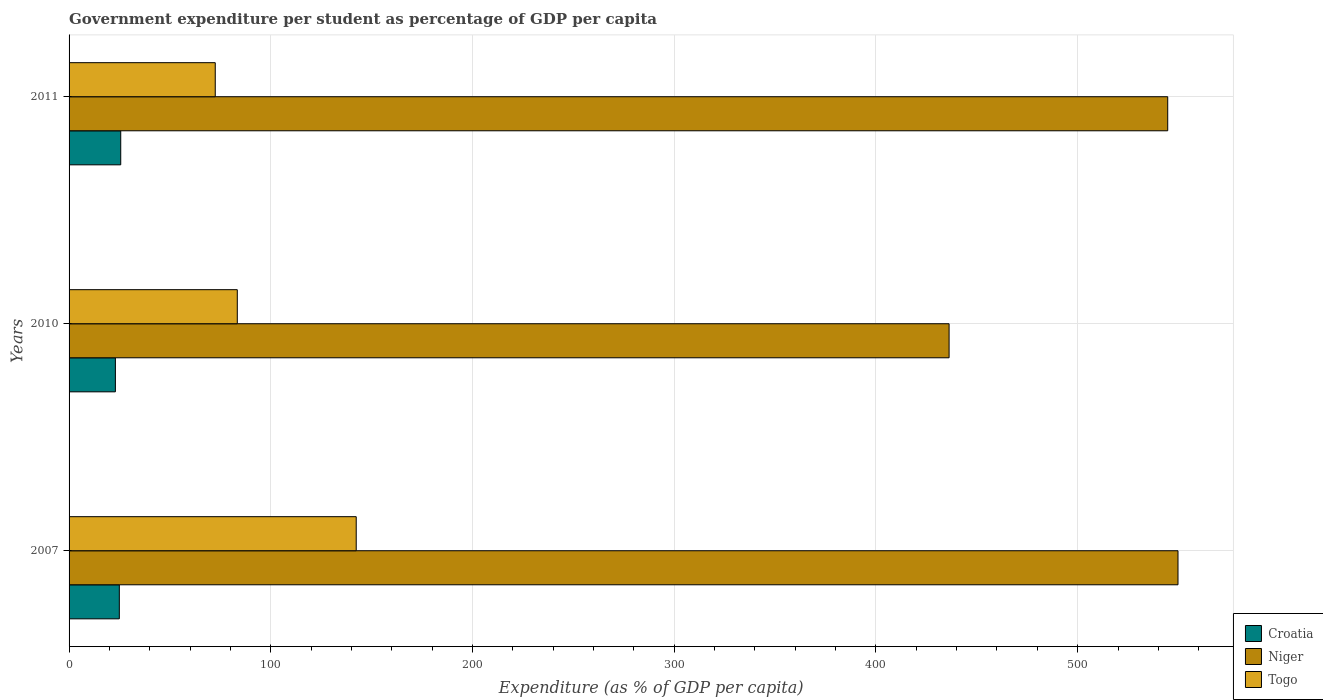How many different coloured bars are there?
Offer a very short reply. 3. Are the number of bars per tick equal to the number of legend labels?
Ensure brevity in your answer.  Yes. How many bars are there on the 2nd tick from the top?
Keep it short and to the point. 3. How many bars are there on the 3rd tick from the bottom?
Keep it short and to the point. 3. What is the percentage of expenditure per student in Niger in 2011?
Offer a very short reply. 544.64. Across all years, what is the maximum percentage of expenditure per student in Togo?
Give a very brief answer. 142.35. Across all years, what is the minimum percentage of expenditure per student in Togo?
Provide a short and direct response. 72.47. In which year was the percentage of expenditure per student in Togo minimum?
Your response must be concise. 2011. What is the total percentage of expenditure per student in Togo in the graph?
Your answer should be very brief. 298.22. What is the difference between the percentage of expenditure per student in Croatia in 2007 and that in 2011?
Provide a succinct answer. -0.7. What is the difference between the percentage of expenditure per student in Niger in 2011 and the percentage of expenditure per student in Togo in 2007?
Make the answer very short. 402.29. What is the average percentage of expenditure per student in Togo per year?
Make the answer very short. 99.41. In the year 2010, what is the difference between the percentage of expenditure per student in Niger and percentage of expenditure per student in Togo?
Give a very brief answer. 352.86. In how many years, is the percentage of expenditure per student in Togo greater than 480 %?
Make the answer very short. 0. What is the ratio of the percentage of expenditure per student in Croatia in 2010 to that in 2011?
Ensure brevity in your answer.  0.9. Is the percentage of expenditure per student in Niger in 2007 less than that in 2010?
Offer a terse response. No. Is the difference between the percentage of expenditure per student in Niger in 2007 and 2010 greater than the difference between the percentage of expenditure per student in Togo in 2007 and 2010?
Provide a succinct answer. Yes. What is the difference between the highest and the second highest percentage of expenditure per student in Niger?
Provide a short and direct response. 5.1. What is the difference between the highest and the lowest percentage of expenditure per student in Niger?
Keep it short and to the point. 113.48. In how many years, is the percentage of expenditure per student in Croatia greater than the average percentage of expenditure per student in Croatia taken over all years?
Your response must be concise. 2. What does the 1st bar from the top in 2007 represents?
Offer a very short reply. Togo. What does the 2nd bar from the bottom in 2011 represents?
Offer a terse response. Niger. Is it the case that in every year, the sum of the percentage of expenditure per student in Togo and percentage of expenditure per student in Niger is greater than the percentage of expenditure per student in Croatia?
Your response must be concise. Yes. Are all the bars in the graph horizontal?
Your answer should be very brief. Yes. How many years are there in the graph?
Your response must be concise. 3. What is the difference between two consecutive major ticks on the X-axis?
Give a very brief answer. 100. How are the legend labels stacked?
Offer a terse response. Vertical. What is the title of the graph?
Keep it short and to the point. Government expenditure per student as percentage of GDP per capita. What is the label or title of the X-axis?
Your answer should be very brief. Expenditure (as % of GDP per capita). What is the label or title of the Y-axis?
Your answer should be compact. Years. What is the Expenditure (as % of GDP per capita) in Croatia in 2007?
Your response must be concise. 24.92. What is the Expenditure (as % of GDP per capita) of Niger in 2007?
Provide a succinct answer. 549.74. What is the Expenditure (as % of GDP per capita) in Togo in 2007?
Your answer should be very brief. 142.35. What is the Expenditure (as % of GDP per capita) in Croatia in 2010?
Give a very brief answer. 22.96. What is the Expenditure (as % of GDP per capita) in Niger in 2010?
Your answer should be very brief. 436.26. What is the Expenditure (as % of GDP per capita) in Togo in 2010?
Make the answer very short. 83.4. What is the Expenditure (as % of GDP per capita) in Croatia in 2011?
Your answer should be compact. 25.61. What is the Expenditure (as % of GDP per capita) in Niger in 2011?
Ensure brevity in your answer.  544.64. What is the Expenditure (as % of GDP per capita) of Togo in 2011?
Your answer should be compact. 72.47. Across all years, what is the maximum Expenditure (as % of GDP per capita) of Croatia?
Your answer should be compact. 25.61. Across all years, what is the maximum Expenditure (as % of GDP per capita) in Niger?
Offer a terse response. 549.74. Across all years, what is the maximum Expenditure (as % of GDP per capita) in Togo?
Offer a very short reply. 142.35. Across all years, what is the minimum Expenditure (as % of GDP per capita) of Croatia?
Provide a short and direct response. 22.96. Across all years, what is the minimum Expenditure (as % of GDP per capita) in Niger?
Offer a very short reply. 436.26. Across all years, what is the minimum Expenditure (as % of GDP per capita) of Togo?
Give a very brief answer. 72.47. What is the total Expenditure (as % of GDP per capita) in Croatia in the graph?
Ensure brevity in your answer.  73.49. What is the total Expenditure (as % of GDP per capita) of Niger in the graph?
Your response must be concise. 1530.64. What is the total Expenditure (as % of GDP per capita) of Togo in the graph?
Keep it short and to the point. 298.21. What is the difference between the Expenditure (as % of GDP per capita) of Croatia in 2007 and that in 2010?
Offer a terse response. 1.96. What is the difference between the Expenditure (as % of GDP per capita) in Niger in 2007 and that in 2010?
Offer a terse response. 113.48. What is the difference between the Expenditure (as % of GDP per capita) in Togo in 2007 and that in 2010?
Offer a terse response. 58.95. What is the difference between the Expenditure (as % of GDP per capita) in Croatia in 2007 and that in 2011?
Keep it short and to the point. -0.7. What is the difference between the Expenditure (as % of GDP per capita) in Niger in 2007 and that in 2011?
Offer a very short reply. 5.09. What is the difference between the Expenditure (as % of GDP per capita) of Togo in 2007 and that in 2011?
Offer a very short reply. 69.88. What is the difference between the Expenditure (as % of GDP per capita) in Croatia in 2010 and that in 2011?
Your answer should be very brief. -2.65. What is the difference between the Expenditure (as % of GDP per capita) in Niger in 2010 and that in 2011?
Your answer should be compact. -108.39. What is the difference between the Expenditure (as % of GDP per capita) of Togo in 2010 and that in 2011?
Your answer should be very brief. 10.93. What is the difference between the Expenditure (as % of GDP per capita) of Croatia in 2007 and the Expenditure (as % of GDP per capita) of Niger in 2010?
Provide a short and direct response. -411.34. What is the difference between the Expenditure (as % of GDP per capita) of Croatia in 2007 and the Expenditure (as % of GDP per capita) of Togo in 2010?
Give a very brief answer. -58.48. What is the difference between the Expenditure (as % of GDP per capita) of Niger in 2007 and the Expenditure (as % of GDP per capita) of Togo in 2010?
Your answer should be compact. 466.34. What is the difference between the Expenditure (as % of GDP per capita) in Croatia in 2007 and the Expenditure (as % of GDP per capita) in Niger in 2011?
Keep it short and to the point. -519.73. What is the difference between the Expenditure (as % of GDP per capita) in Croatia in 2007 and the Expenditure (as % of GDP per capita) in Togo in 2011?
Give a very brief answer. -47.55. What is the difference between the Expenditure (as % of GDP per capita) of Niger in 2007 and the Expenditure (as % of GDP per capita) of Togo in 2011?
Give a very brief answer. 477.27. What is the difference between the Expenditure (as % of GDP per capita) of Croatia in 2010 and the Expenditure (as % of GDP per capita) of Niger in 2011?
Offer a terse response. -521.68. What is the difference between the Expenditure (as % of GDP per capita) in Croatia in 2010 and the Expenditure (as % of GDP per capita) in Togo in 2011?
Your answer should be compact. -49.51. What is the difference between the Expenditure (as % of GDP per capita) of Niger in 2010 and the Expenditure (as % of GDP per capita) of Togo in 2011?
Provide a short and direct response. 363.79. What is the average Expenditure (as % of GDP per capita) in Croatia per year?
Make the answer very short. 24.5. What is the average Expenditure (as % of GDP per capita) in Niger per year?
Your answer should be very brief. 510.21. What is the average Expenditure (as % of GDP per capita) in Togo per year?
Keep it short and to the point. 99.41. In the year 2007, what is the difference between the Expenditure (as % of GDP per capita) of Croatia and Expenditure (as % of GDP per capita) of Niger?
Ensure brevity in your answer.  -524.82. In the year 2007, what is the difference between the Expenditure (as % of GDP per capita) of Croatia and Expenditure (as % of GDP per capita) of Togo?
Give a very brief answer. -117.43. In the year 2007, what is the difference between the Expenditure (as % of GDP per capita) in Niger and Expenditure (as % of GDP per capita) in Togo?
Offer a very short reply. 407.39. In the year 2010, what is the difference between the Expenditure (as % of GDP per capita) of Croatia and Expenditure (as % of GDP per capita) of Niger?
Offer a terse response. -413.3. In the year 2010, what is the difference between the Expenditure (as % of GDP per capita) in Croatia and Expenditure (as % of GDP per capita) in Togo?
Offer a terse response. -60.44. In the year 2010, what is the difference between the Expenditure (as % of GDP per capita) in Niger and Expenditure (as % of GDP per capita) in Togo?
Provide a succinct answer. 352.86. In the year 2011, what is the difference between the Expenditure (as % of GDP per capita) of Croatia and Expenditure (as % of GDP per capita) of Niger?
Provide a short and direct response. -519.03. In the year 2011, what is the difference between the Expenditure (as % of GDP per capita) of Croatia and Expenditure (as % of GDP per capita) of Togo?
Provide a short and direct response. -46.85. In the year 2011, what is the difference between the Expenditure (as % of GDP per capita) in Niger and Expenditure (as % of GDP per capita) in Togo?
Keep it short and to the point. 472.18. What is the ratio of the Expenditure (as % of GDP per capita) of Croatia in 2007 to that in 2010?
Offer a terse response. 1.09. What is the ratio of the Expenditure (as % of GDP per capita) of Niger in 2007 to that in 2010?
Keep it short and to the point. 1.26. What is the ratio of the Expenditure (as % of GDP per capita) of Togo in 2007 to that in 2010?
Offer a very short reply. 1.71. What is the ratio of the Expenditure (as % of GDP per capita) in Croatia in 2007 to that in 2011?
Give a very brief answer. 0.97. What is the ratio of the Expenditure (as % of GDP per capita) of Niger in 2007 to that in 2011?
Your response must be concise. 1.01. What is the ratio of the Expenditure (as % of GDP per capita) of Togo in 2007 to that in 2011?
Offer a very short reply. 1.96. What is the ratio of the Expenditure (as % of GDP per capita) of Croatia in 2010 to that in 2011?
Make the answer very short. 0.9. What is the ratio of the Expenditure (as % of GDP per capita) of Niger in 2010 to that in 2011?
Provide a short and direct response. 0.8. What is the ratio of the Expenditure (as % of GDP per capita) of Togo in 2010 to that in 2011?
Your answer should be compact. 1.15. What is the difference between the highest and the second highest Expenditure (as % of GDP per capita) in Croatia?
Provide a short and direct response. 0.7. What is the difference between the highest and the second highest Expenditure (as % of GDP per capita) in Niger?
Keep it short and to the point. 5.09. What is the difference between the highest and the second highest Expenditure (as % of GDP per capita) in Togo?
Provide a short and direct response. 58.95. What is the difference between the highest and the lowest Expenditure (as % of GDP per capita) of Croatia?
Give a very brief answer. 2.65. What is the difference between the highest and the lowest Expenditure (as % of GDP per capita) in Niger?
Ensure brevity in your answer.  113.48. What is the difference between the highest and the lowest Expenditure (as % of GDP per capita) in Togo?
Provide a short and direct response. 69.88. 